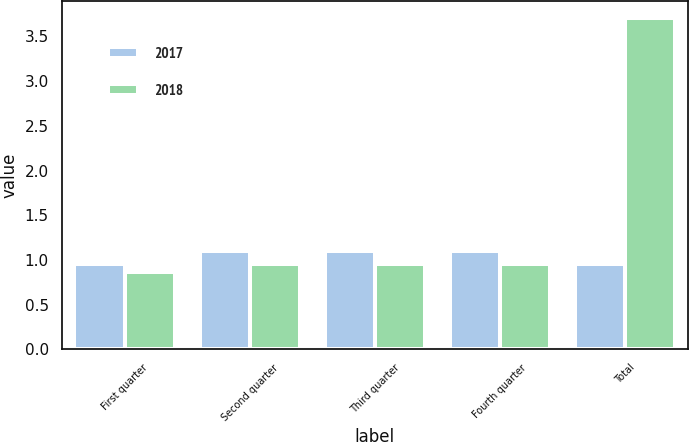Convert chart to OTSL. <chart><loc_0><loc_0><loc_500><loc_500><stacked_bar_chart><ecel><fcel>First quarter<fcel>Second quarter<fcel>Third quarter<fcel>Fourth quarter<fcel>Total<nl><fcel>2017<fcel>0.95<fcel>1.1<fcel>1.1<fcel>1.1<fcel>0.95<nl><fcel>2018<fcel>0.86<fcel>0.95<fcel>0.95<fcel>0.95<fcel>3.71<nl></chart> 